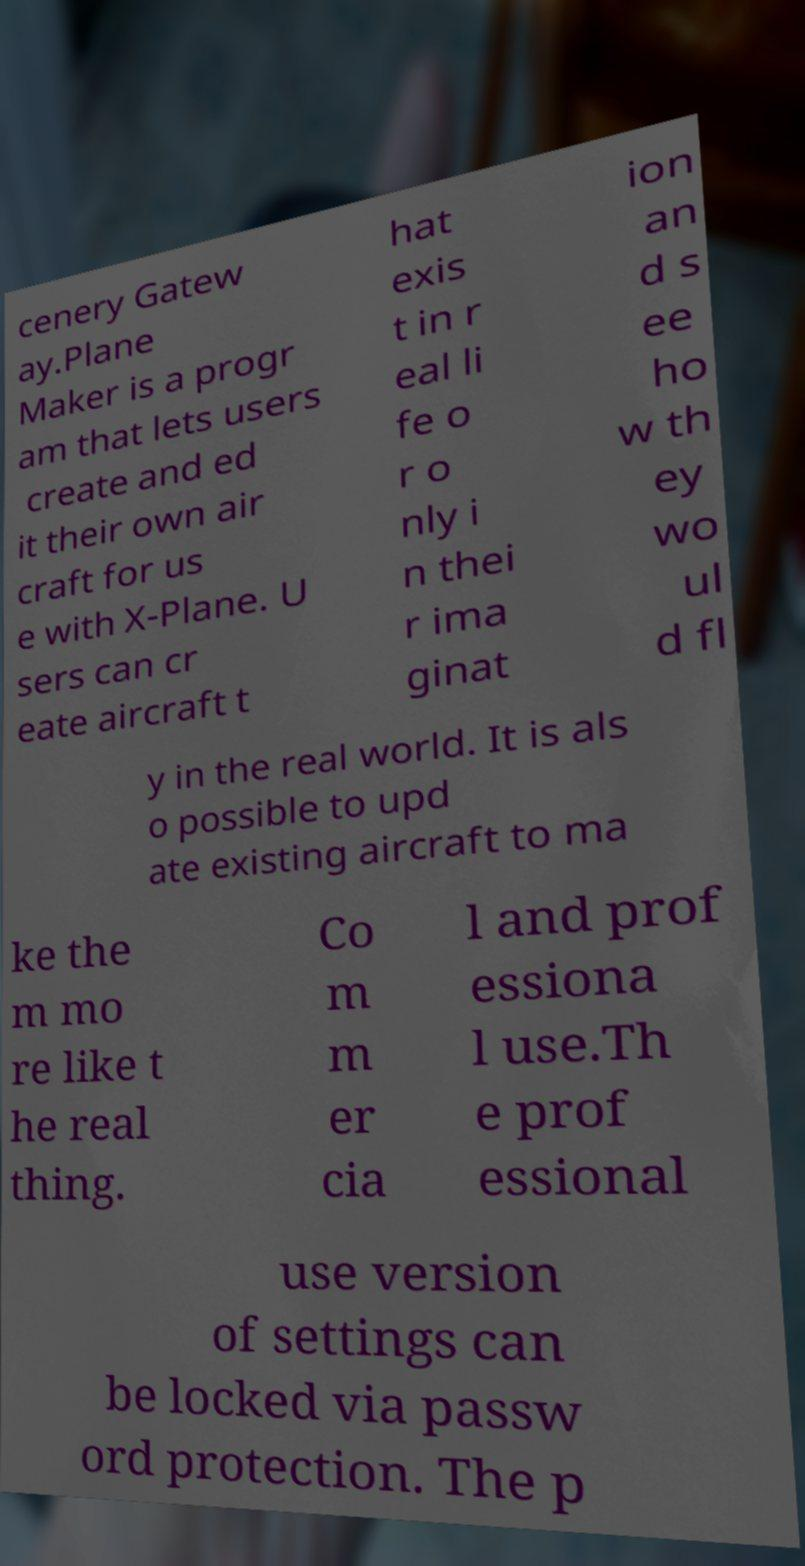Can you read and provide the text displayed in the image?This photo seems to have some interesting text. Can you extract and type it out for me? cenery Gatew ay.Plane Maker is a progr am that lets users create and ed it their own air craft for us e with X-Plane. U sers can cr eate aircraft t hat exis t in r eal li fe o r o nly i n thei r ima ginat ion an d s ee ho w th ey wo ul d fl y in the real world. It is als o possible to upd ate existing aircraft to ma ke the m mo re like t he real thing. Co m m er cia l and prof essiona l use.Th e prof essional use version of settings can be locked via passw ord protection. The p 